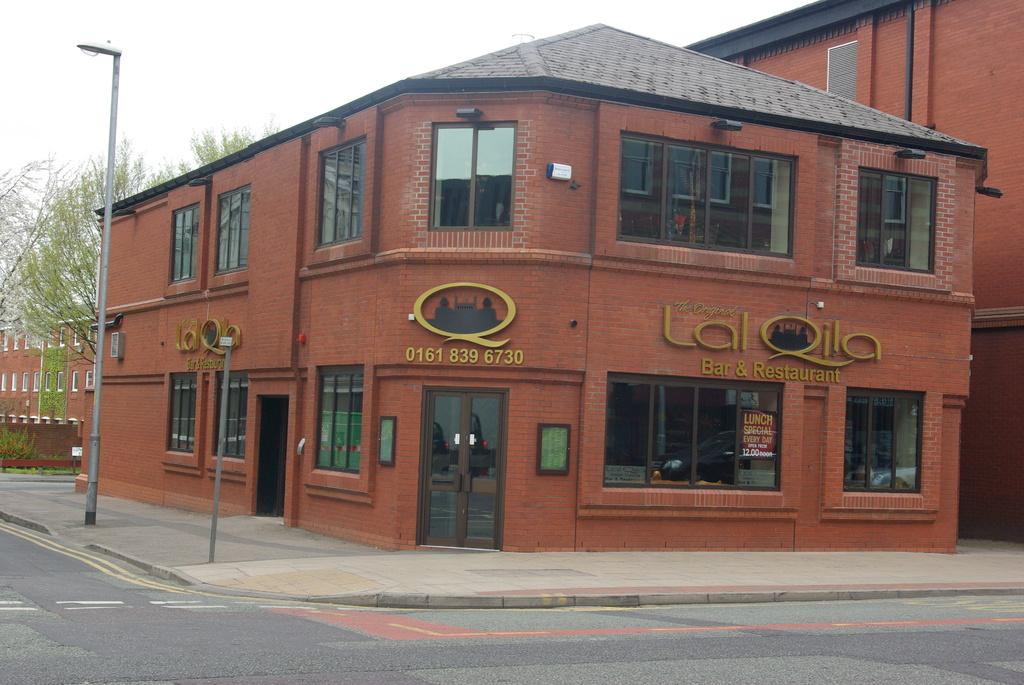What type of pathway is visible in the image? There is a road in the image. What structures can be seen along the road? There are two poles and a building visible in the image. What type of vegetation is present in the image? There are trees in the image. What is visible at the top of the image? The sky is visible at the top of the image. What type of music can be heard playing from the clocks in the image? There are no clocks present in the image, and therefore no music can be heard. 